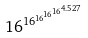Convert formula to latex. <formula><loc_0><loc_0><loc_500><loc_500>1 6 ^ { 1 6 ^ { 1 6 ^ { 1 6 ^ { 1 6 ^ { 4 . 5 2 7 } } } } }</formula> 